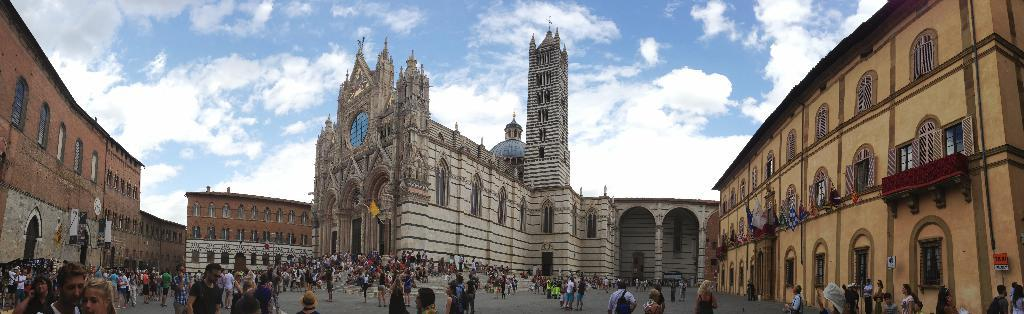Who or what can be seen in the image? There are people in the image. What type of structures are visible in the image? There are buildings in the image. What architectural feature can be seen in the image? There is an arch in the image. What might be used for communication or displaying information in the image? There is written text on a board in the image. What can be seen flying in the image? There are flags in the image. What is visible at the top of the image? The sky is visible at the top of the image. What can be observed in the sky? Clouds are present in the sky. How many forks can be seen in the image? There are no forks present in the image. What type of girls can be seen playing in the image? There is no mention of girls or any playful activity in the image. 